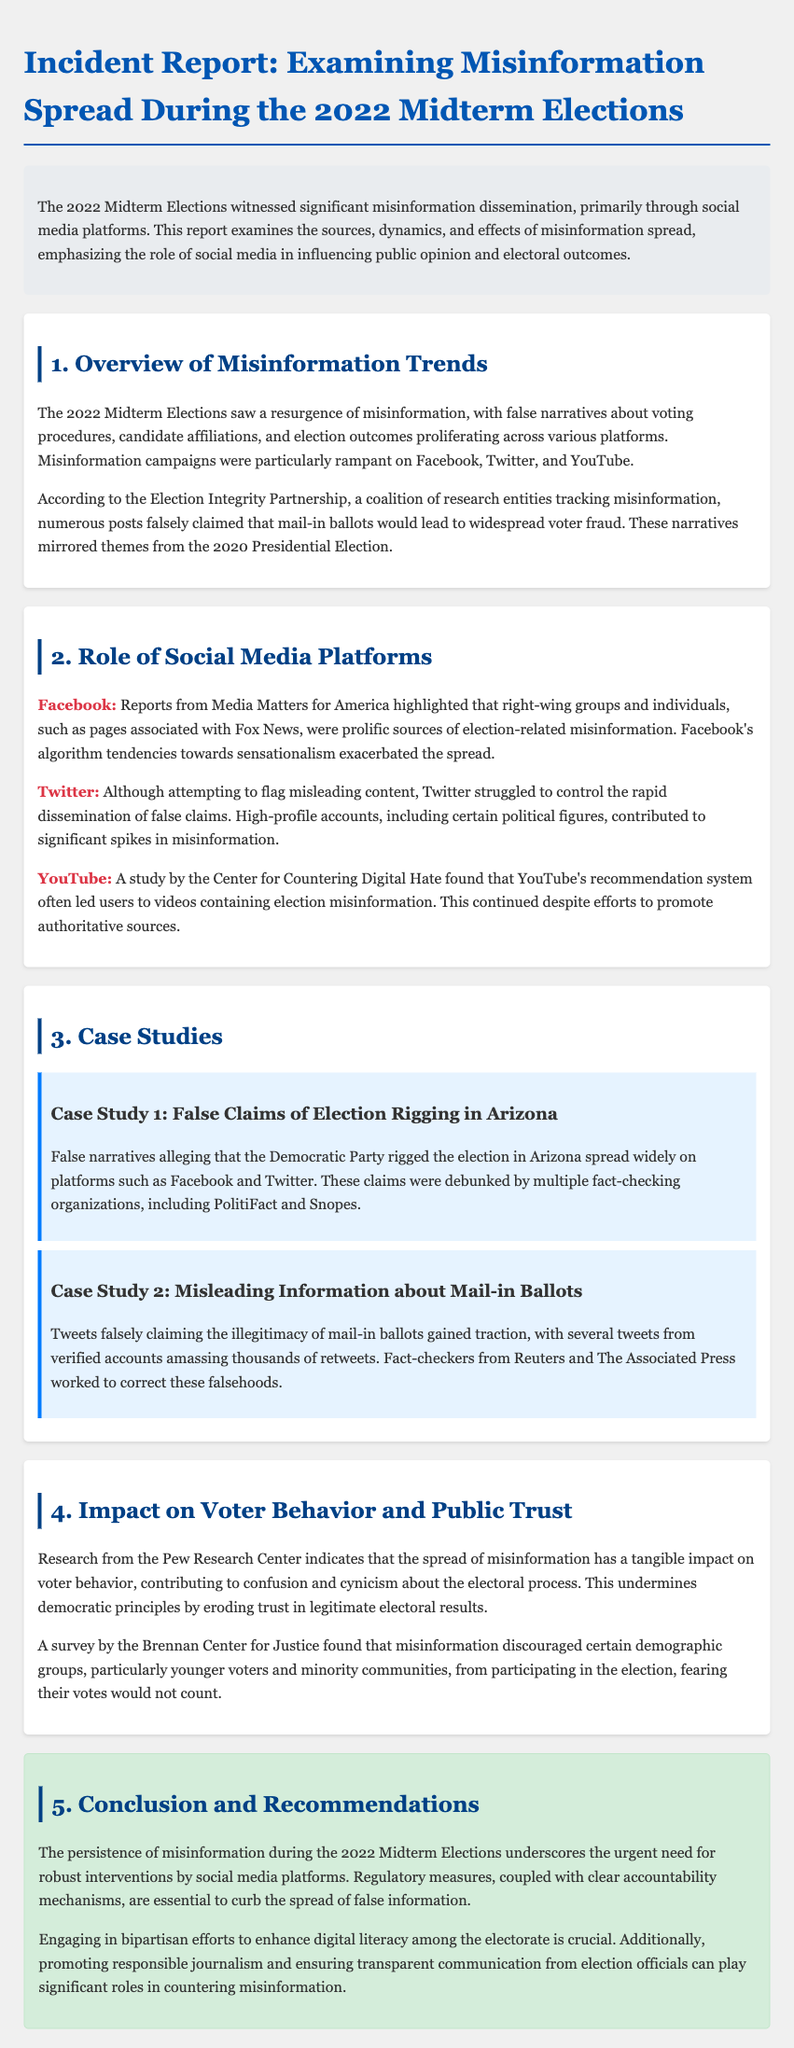What were the primary platforms for misinformation spread? The report states that misinformation campaigns were particularly rampant on Facebook, Twitter, and YouTube.
Answer: Facebook, Twitter, YouTube Who highlighted the role of right-wing groups in spreading misinformation? Reports from Media Matters for America highlighted that right-wing groups and individuals, such as pages associated with Fox News, were prolific sources of election-related misinformation.
Answer: Media Matters for America What type of misinformation was prevalent regarding mail-in ballots? Numerous posts falsely claimed that mail-in ballots would lead to widespread voter fraud.
Answer: Voter fraud Which case study involved false claims about the Democratic Party? False narratives alleging that the Democratic Party rigged the election in Arizona spread widely on platforms such as Facebook and Twitter.
Answer: Arizona What effect did misinformation have on younger voters? A survey by the Brennan Center for Justice found that misinformation discouraged certain demographic groups, particularly younger voters and minority communities, from participating in the election.
Answer: Discouraged participation What is a recommended measure to combat misinformation according to the report? The report suggests that regulatory measures, coupled with clear accountability mechanisms, are essential to curb the spread of false information.
Answer: Regulatory measures 